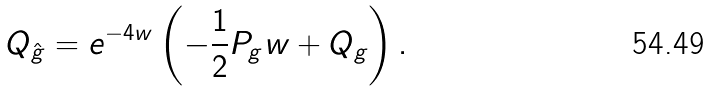Convert formula to latex. <formula><loc_0><loc_0><loc_500><loc_500>Q _ { \hat { g } } = e ^ { - 4 w } \left ( - \frac { 1 } { 2 } P _ { g } w + Q _ { g } \right ) .</formula> 